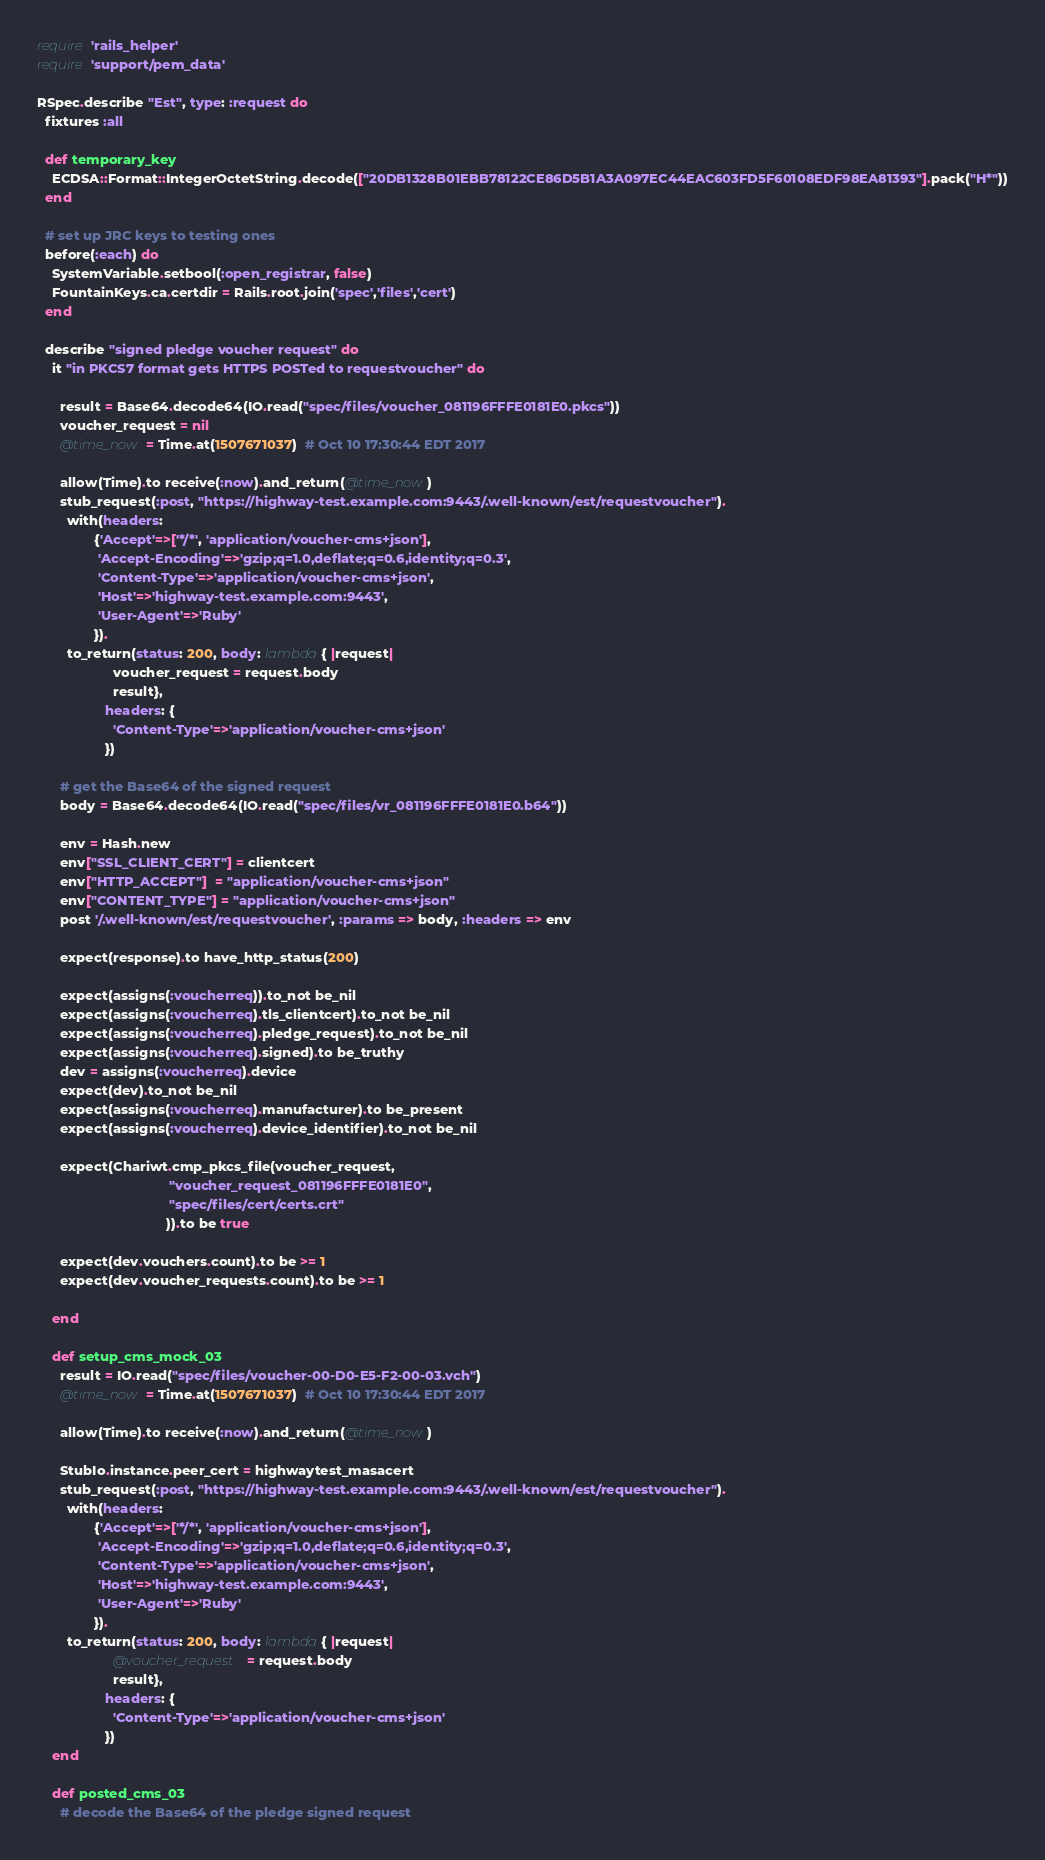Convert code to text. <code><loc_0><loc_0><loc_500><loc_500><_Ruby_>require 'rails_helper'
require 'support/pem_data'

RSpec.describe "Est", type: :request do
  fixtures :all

  def temporary_key
    ECDSA::Format::IntegerOctetString.decode(["20DB1328B01EBB78122CE86D5B1A3A097EC44EAC603FD5F60108EDF98EA81393"].pack("H*"))
  end

  # set up JRC keys to testing ones
  before(:each) do
    SystemVariable.setbool(:open_registrar, false)
    FountainKeys.ca.certdir = Rails.root.join('spec','files','cert')
  end

  describe "signed pledge voucher request" do
    it "in PKCS7 format gets HTTPS POSTed to requestvoucher" do

      result = Base64.decode64(IO.read("spec/files/voucher_081196FFFE0181E0.pkcs"))
      voucher_request = nil
      @time_now = Time.at(1507671037)  # Oct 10 17:30:44 EDT 2017

      allow(Time).to receive(:now).and_return(@time_now)
      stub_request(:post, "https://highway-test.example.com:9443/.well-known/est/requestvoucher").
        with(headers:
               {'Accept'=>['*/*', 'application/voucher-cms+json'],
                'Accept-Encoding'=>'gzip;q=1.0,deflate;q=0.6,identity;q=0.3',
                'Content-Type'=>'application/voucher-cms+json',
                'Host'=>'highway-test.example.com:9443',
                'User-Agent'=>'Ruby'
               }).
        to_return(status: 200, body: lambda { |request|
                    voucher_request = request.body
                    result},
                  headers: {
                    'Content-Type'=>'application/voucher-cms+json'
                  })

      # get the Base64 of the signed request
      body = Base64.decode64(IO.read("spec/files/vr_081196FFFE0181E0.b64"))

      env = Hash.new
      env["SSL_CLIENT_CERT"] = clientcert
      env["HTTP_ACCEPT"]  = "application/voucher-cms+json"
      env["CONTENT_TYPE"] = "application/voucher-cms+json"
      post '/.well-known/est/requestvoucher', :params => body, :headers => env

      expect(response).to have_http_status(200)

      expect(assigns(:voucherreq)).to_not be_nil
      expect(assigns(:voucherreq).tls_clientcert).to_not be_nil
      expect(assigns(:voucherreq).pledge_request).to_not be_nil
      expect(assigns(:voucherreq).signed).to be_truthy
      dev = assigns(:voucherreq).device
      expect(dev).to_not be_nil
      expect(assigns(:voucherreq).manufacturer).to be_present
      expect(assigns(:voucherreq).device_identifier).to_not be_nil

      expect(Chariwt.cmp_pkcs_file(voucher_request,
                                   "voucher_request_081196FFFE0181E0",
                                   "spec/files/cert/certs.crt"
                                  )).to be true

      expect(dev.vouchers.count).to be >= 1
      expect(dev.voucher_requests.count).to be >= 1

    end

    def setup_cms_mock_03
      result = IO.read("spec/files/voucher-00-D0-E5-F2-00-03.vch")
      @time_now = Time.at(1507671037)  # Oct 10 17:30:44 EDT 2017

      allow(Time).to receive(:now).and_return(@time_now)

      StubIo.instance.peer_cert = highwaytest_masacert
      stub_request(:post, "https://highway-test.example.com:9443/.well-known/est/requestvoucher").
        with(headers:
               {'Accept'=>['*/*', 'application/voucher-cms+json'],
                'Accept-Encoding'=>'gzip;q=1.0,deflate;q=0.6,identity;q=0.3',
                'Content-Type'=>'application/voucher-cms+json',
                'Host'=>'highway-test.example.com:9443',
                'User-Agent'=>'Ruby'
               }).
        to_return(status: 200, body: lambda { |request|
                    @voucher_request = request.body
                    result},
                  headers: {
                    'Content-Type'=>'application/voucher-cms+json'
                  })
    end

    def posted_cms_03
      # decode the Base64 of the pledge signed request</code> 